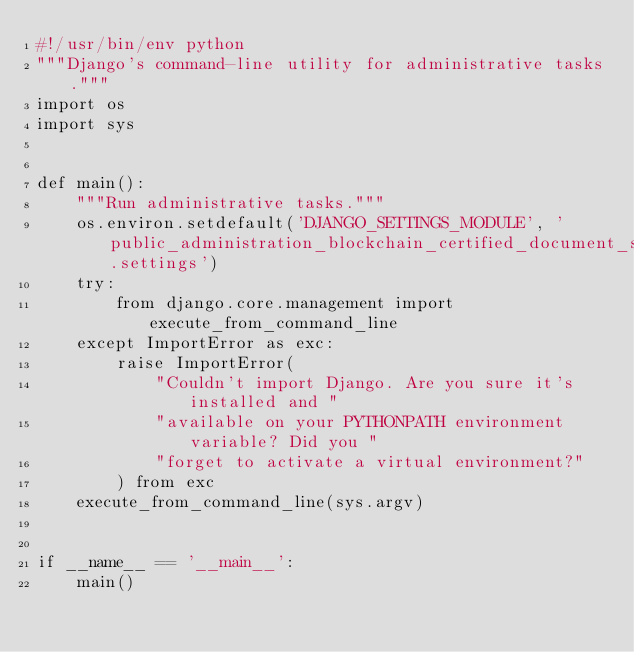Convert code to text. <code><loc_0><loc_0><loc_500><loc_500><_Python_>#!/usr/bin/env python
"""Django's command-line utility for administrative tasks."""
import os
import sys


def main():
    """Run administrative tasks."""
    os.environ.setdefault('DJANGO_SETTINGS_MODULE', 'public_administration_blockchain_certified_document_sharing.settings')
    try:
        from django.core.management import execute_from_command_line
    except ImportError as exc:
        raise ImportError(
            "Couldn't import Django. Are you sure it's installed and "
            "available on your PYTHONPATH environment variable? Did you "
            "forget to activate a virtual environment?"
        ) from exc
    execute_from_command_line(sys.argv)


if __name__ == '__main__':
    main()
</code> 